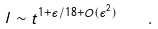<formula> <loc_0><loc_0><loc_500><loc_500>l \sim t ^ { 1 + \epsilon / 1 8 + O ( \epsilon ^ { 2 } ) } \quad .</formula> 